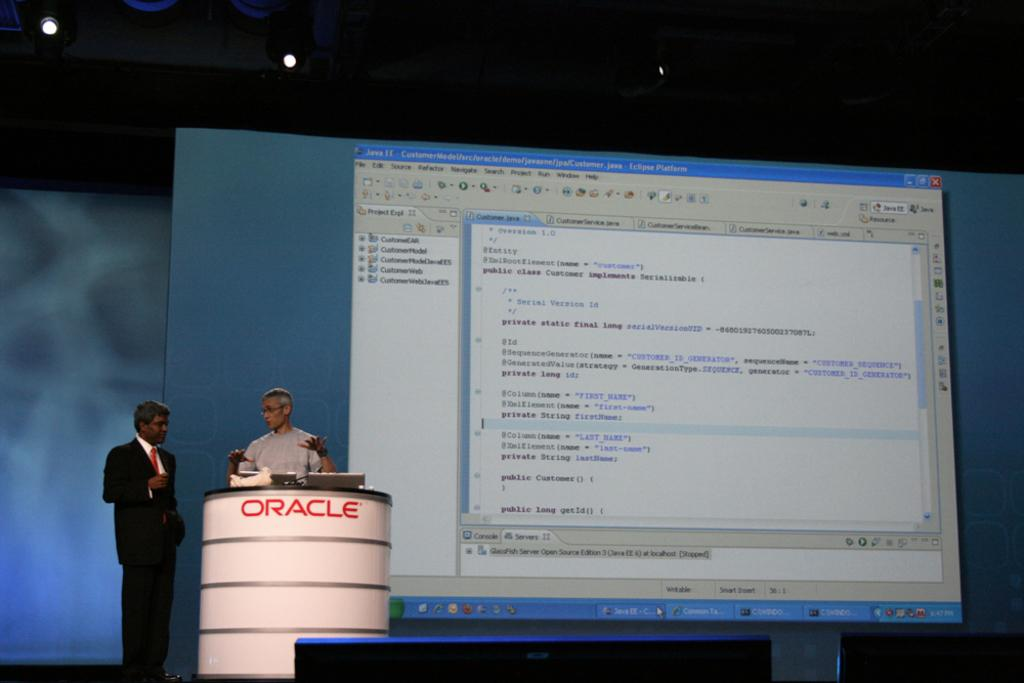Provide a one-sentence caption for the provided image. Two men speak in a presentation near an Oracle podium. 